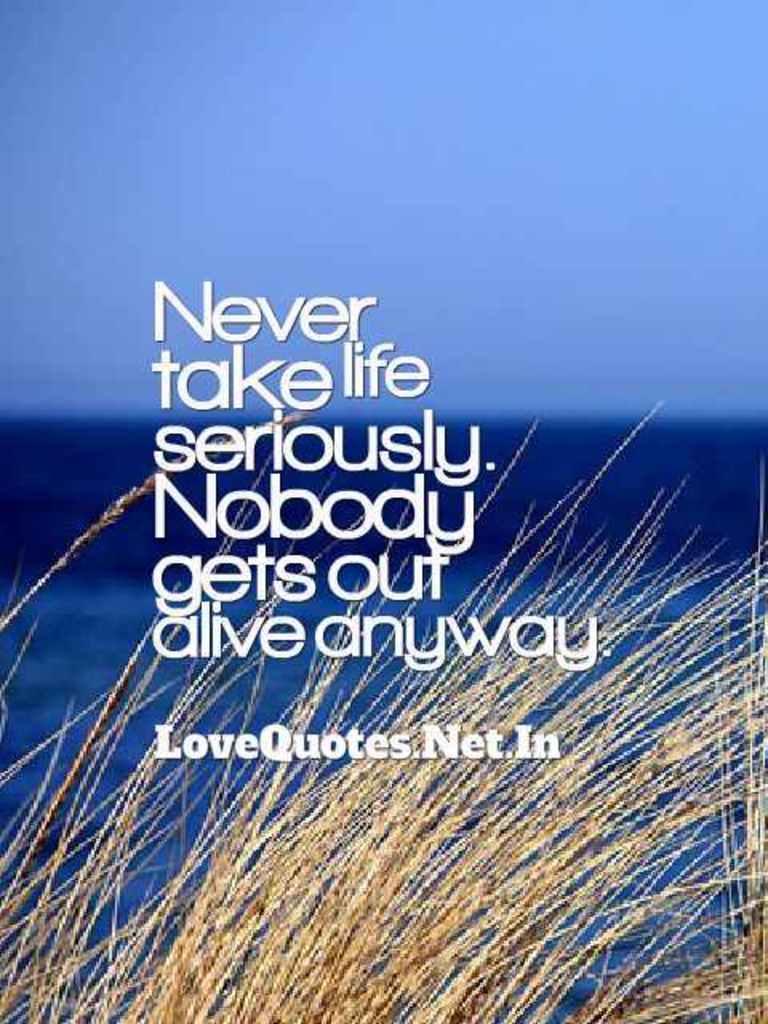Could you give a brief overview of what you see in this image? This picture is clicked outside. In the foreground we can see the dry grass. In the background there is a sky and some other objects. In the center we can see the text on the image. 